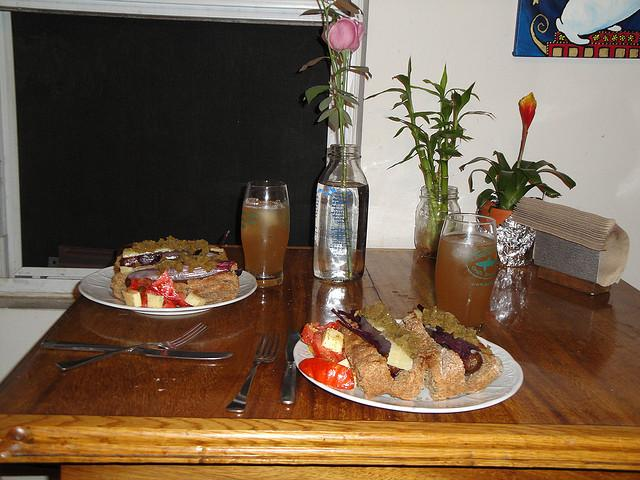What are the items in the brown and grey receptacle for? napkins 